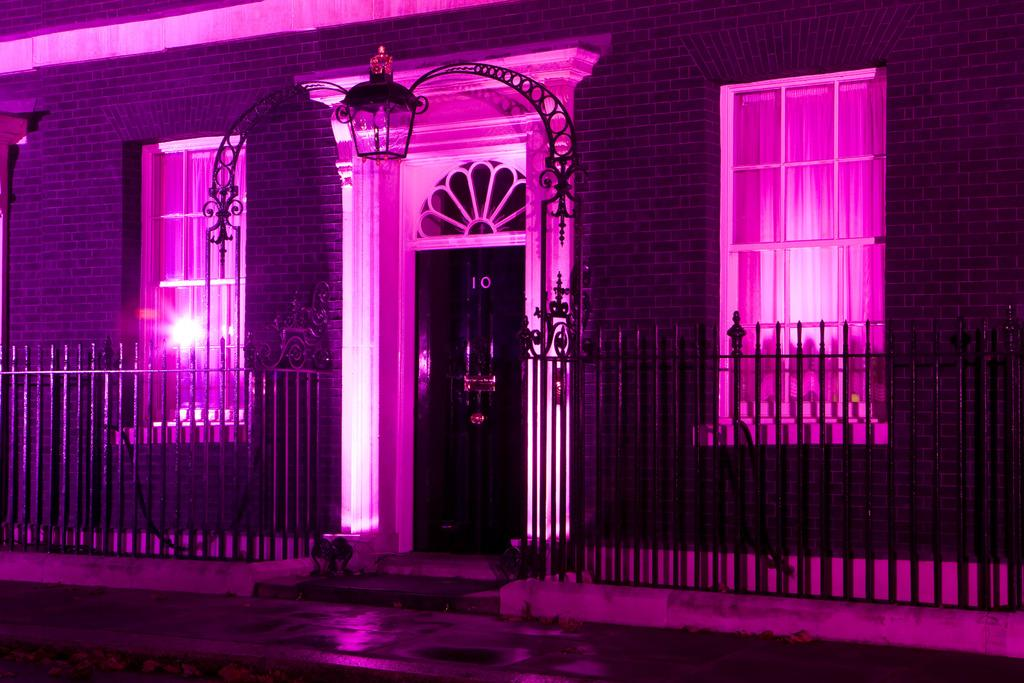What is the main structure in the image? There is a building in the image. What feature can be seen on the building? The building has windows. What is located in front of the building? There is a railing in front of the building. Can you tell me how many snails are crawling on the windows of the building in the image? There are no snails visible on the windows of the building in the image. What type of whip is being used to clean the railing in the image? There is no whip present in the image; the railing is not being cleaned. 